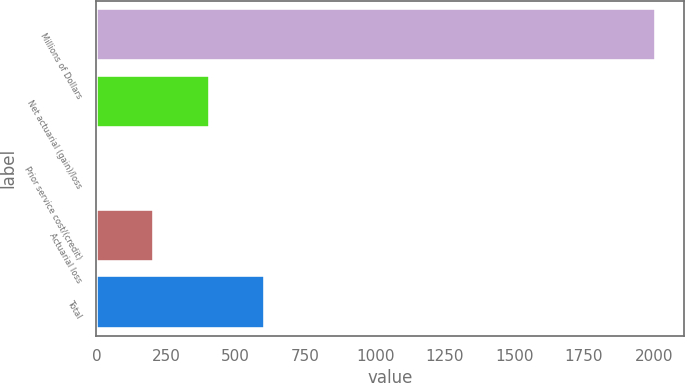<chart> <loc_0><loc_0><loc_500><loc_500><bar_chart><fcel>Millions of Dollars<fcel>Net actuarial (gain)/loss<fcel>Prior service cost/(credit)<fcel>Actuarial loss<fcel>Total<nl><fcel>2007<fcel>406.2<fcel>6<fcel>206.1<fcel>606.3<nl></chart> 